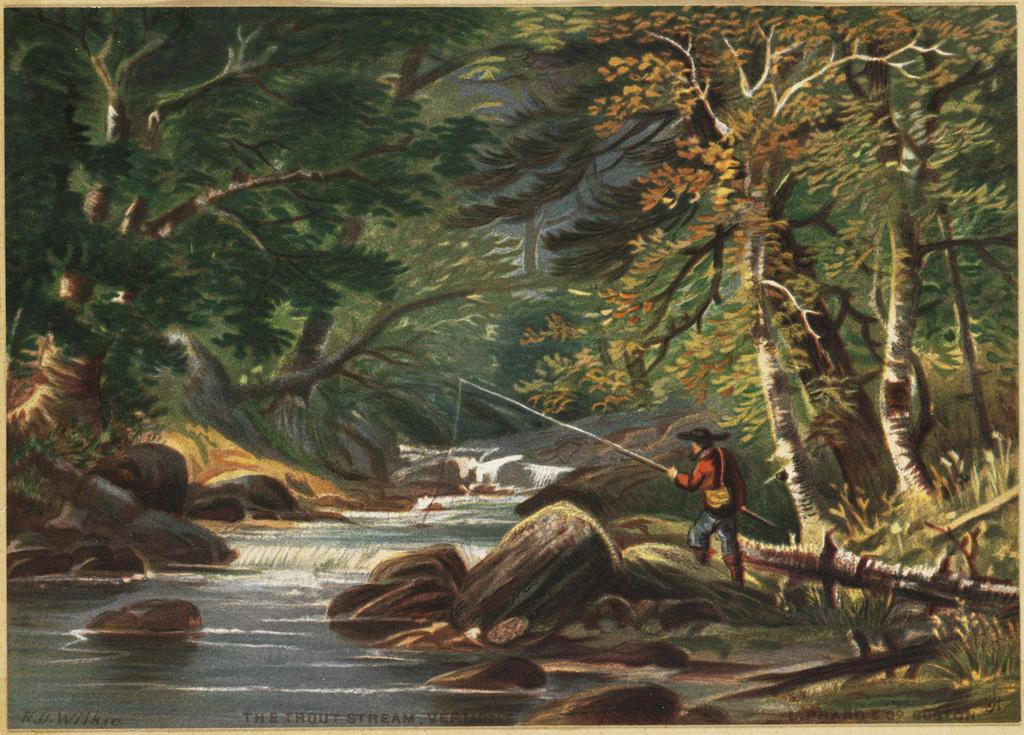What type of artwork is depicted in the image? The image is a painting. What natural feature is on the left side of the painting? There is a river on the left side of the painting. What objects are near the river? There are rocks near the river. What is the person on the right side of the painting doing? The person is standing on the right side of the painting and is fishing. What can be seen in the background of the painting? There are many trees in the background of the painting. What type of party is being held near the river in the painting? There is no party depicted in the painting; it features a person fishing near a river. What toothbrush is being used by the person in the painting? There is no toothbrush present in the painting; the person is fishing with a fishing rod. 